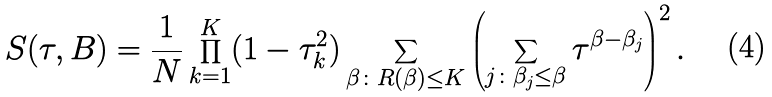Convert formula to latex. <formula><loc_0><loc_0><loc_500><loc_500>S ( \tau , B ) = \frac { 1 } { N } \prod _ { k = 1 } ^ { K } ( 1 - \tau _ { k } ^ { 2 } ) \sum _ { \beta \colon R ( \beta ) \leq K } \left ( \sum _ { j \colon \beta _ { j } \leq \beta } \tau ^ { \beta - \beta _ { j } } \right ) ^ { 2 } .</formula> 